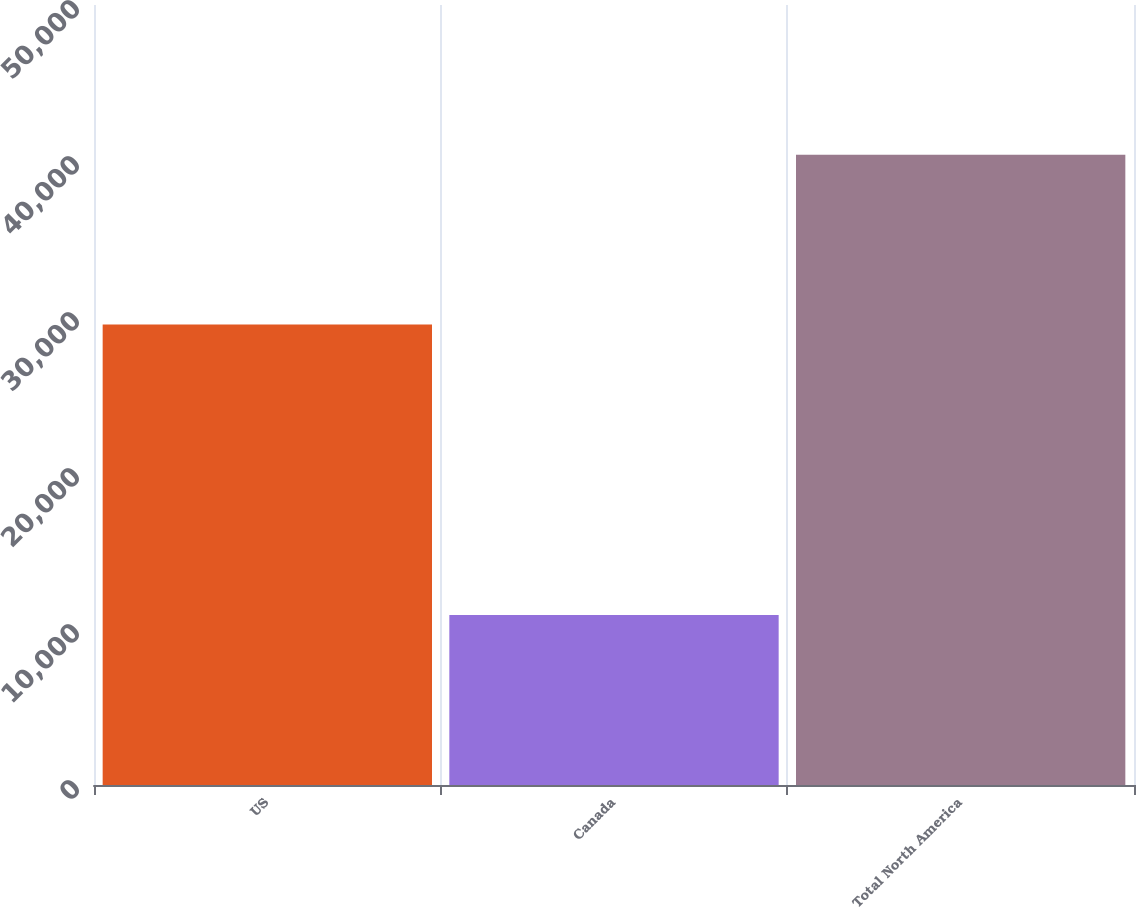Convert chart to OTSL. <chart><loc_0><loc_0><loc_500><loc_500><bar_chart><fcel>US<fcel>Canada<fcel>Total North America<nl><fcel>29513<fcel>10894<fcel>40407<nl></chart> 